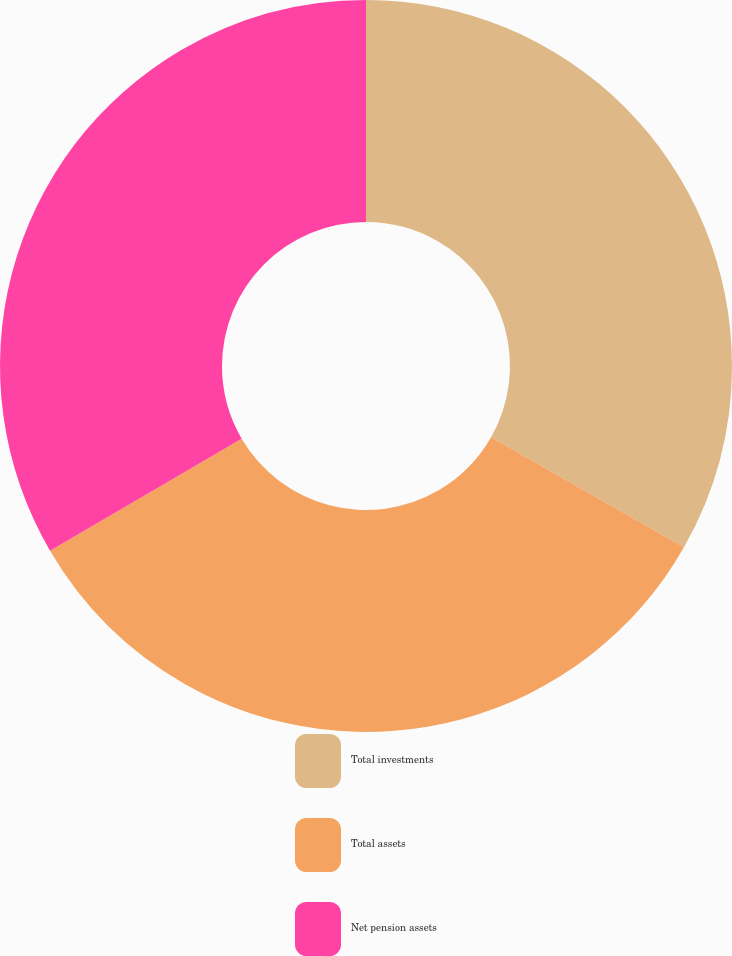Convert chart to OTSL. <chart><loc_0><loc_0><loc_500><loc_500><pie_chart><fcel>Total investments<fcel>Total assets<fcel>Net pension assets<nl><fcel>33.25%<fcel>33.33%<fcel>33.42%<nl></chart> 